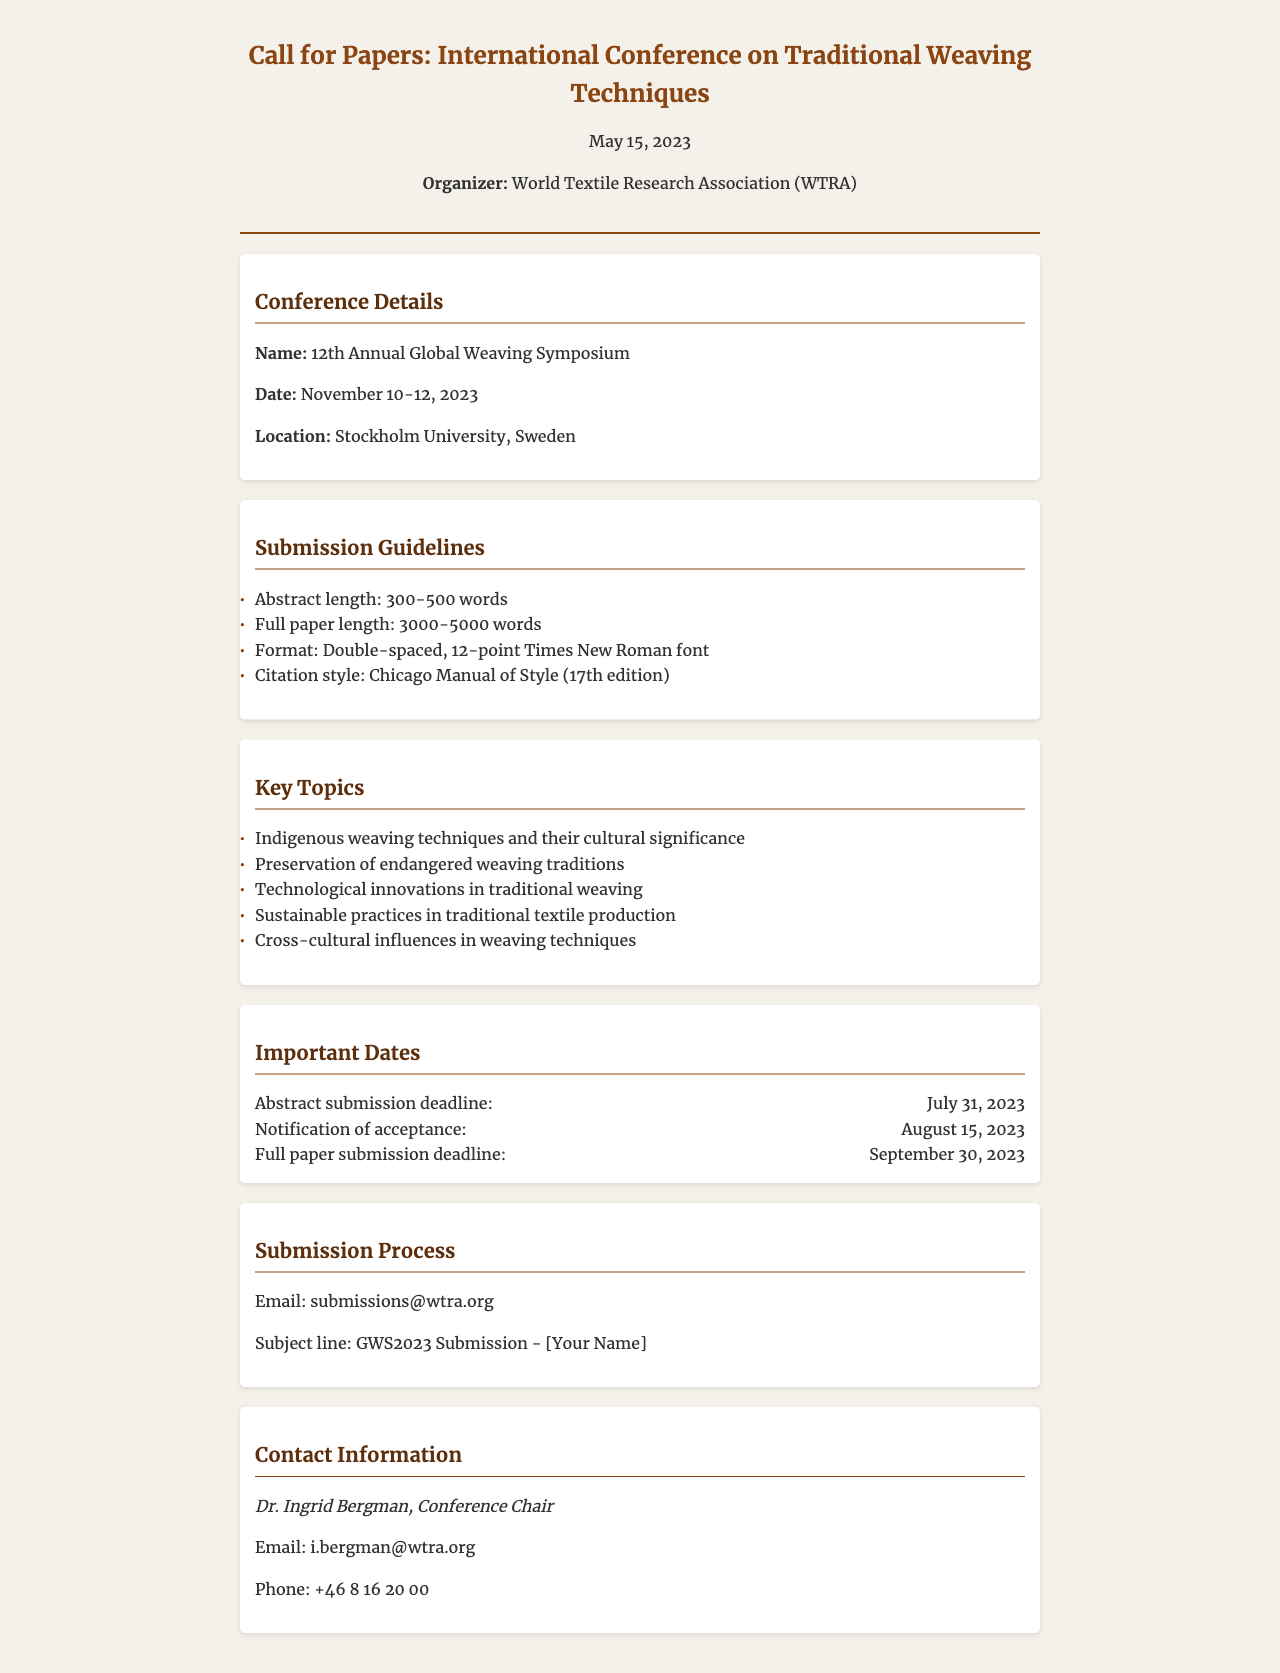What is the name of the conference? The name of the conference is provided in the conference details section.
Answer: 12th Annual Global Weaving Symposium When is the abstract submission deadline? The deadline details are listed under the important dates section.
Answer: July 31, 2023 Who is the conference chair? The contact information section includes the name of the conference chair.
Answer: Dr. Ingrid Bergman How long should the full paper be? The submission guidelines specify the required length for full papers.
Answer: 3000-5000 words What is the email for submissions? The submission process provides the email address required for sending submissions.
Answer: submissions@wtra.org Which city will the conference take place in? The location of the conference is specified in the conference details section.
Answer: Stockholm What citation style should be used? The submission guidelines indicate the citation style that must be followed.
Answer: Chicago Manual of Style (17th edition) What date is the notification of acceptance? The important dates section contains the notification of acceptance date.
Answer: August 15, 2023 What is one key topic of the conference? The key topics section lists the themes that would be discussed at the conference.
Answer: Indigenous weaving techniques and their cultural significance 